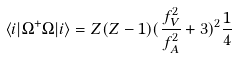Convert formula to latex. <formula><loc_0><loc_0><loc_500><loc_500>\langle i | \Omega ^ { + } \Omega | i \rangle = Z ( Z - 1 ) ( \frac { f _ { V } ^ { 2 } } { f _ { A } ^ { 2 } } + 3 ) ^ { 2 } \frac { 1 } { 4 }</formula> 